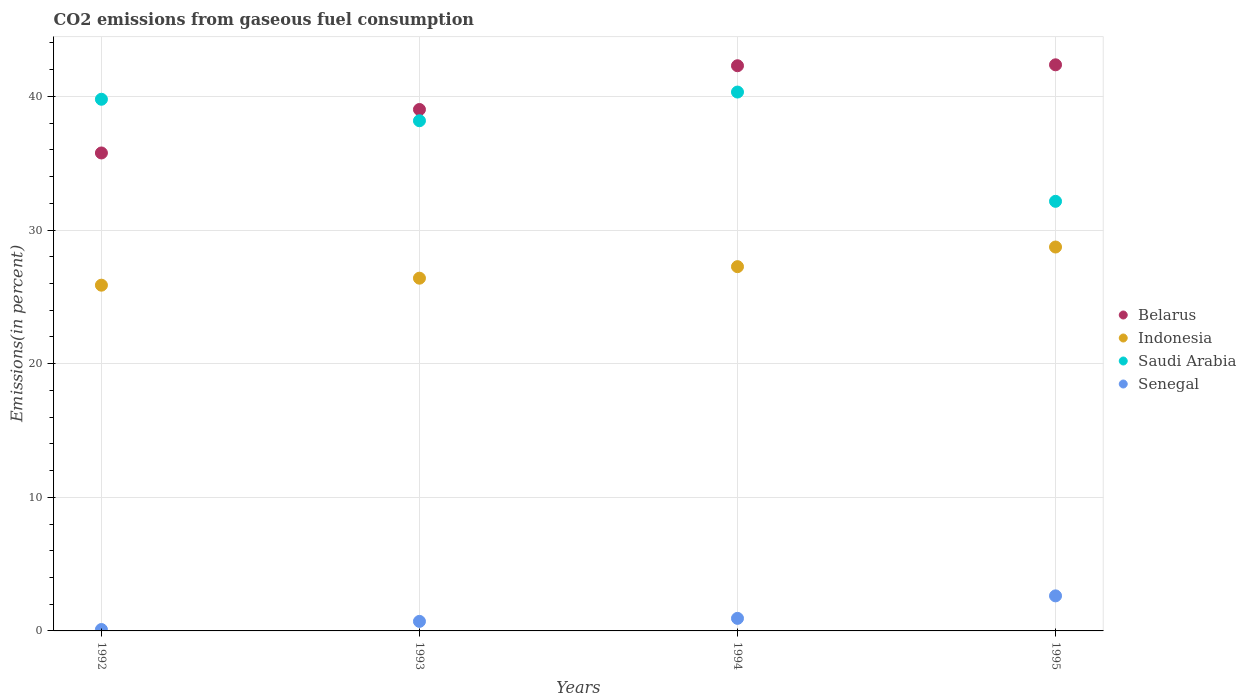How many different coloured dotlines are there?
Provide a succinct answer. 4. Is the number of dotlines equal to the number of legend labels?
Ensure brevity in your answer.  Yes. What is the total CO2 emitted in Senegal in 1994?
Provide a succinct answer. 0.94. Across all years, what is the maximum total CO2 emitted in Indonesia?
Ensure brevity in your answer.  28.73. Across all years, what is the minimum total CO2 emitted in Senegal?
Keep it short and to the point. 0.11. What is the total total CO2 emitted in Indonesia in the graph?
Make the answer very short. 108.26. What is the difference between the total CO2 emitted in Indonesia in 1994 and that in 1995?
Offer a terse response. -1.47. What is the difference between the total CO2 emitted in Saudi Arabia in 1993 and the total CO2 emitted in Senegal in 1994?
Give a very brief answer. 37.24. What is the average total CO2 emitted in Belarus per year?
Your answer should be compact. 39.86. In the year 1995, what is the difference between the total CO2 emitted in Senegal and total CO2 emitted in Indonesia?
Your answer should be very brief. -26.11. What is the ratio of the total CO2 emitted in Belarus in 1992 to that in 1993?
Give a very brief answer. 0.92. Is the total CO2 emitted in Belarus in 1993 less than that in 1994?
Your answer should be compact. Yes. What is the difference between the highest and the second highest total CO2 emitted in Indonesia?
Provide a short and direct response. 1.47. What is the difference between the highest and the lowest total CO2 emitted in Saudi Arabia?
Offer a very short reply. 8.18. In how many years, is the total CO2 emitted in Indonesia greater than the average total CO2 emitted in Indonesia taken over all years?
Your response must be concise. 2. Is it the case that in every year, the sum of the total CO2 emitted in Indonesia and total CO2 emitted in Belarus  is greater than the sum of total CO2 emitted in Saudi Arabia and total CO2 emitted in Senegal?
Your answer should be compact. Yes. Is the total CO2 emitted in Indonesia strictly greater than the total CO2 emitted in Senegal over the years?
Give a very brief answer. Yes. Is the total CO2 emitted in Saudi Arabia strictly less than the total CO2 emitted in Belarus over the years?
Your response must be concise. No. Are the values on the major ticks of Y-axis written in scientific E-notation?
Your answer should be very brief. No. Does the graph contain grids?
Offer a terse response. Yes. What is the title of the graph?
Provide a succinct answer. CO2 emissions from gaseous fuel consumption. What is the label or title of the X-axis?
Your answer should be very brief. Years. What is the label or title of the Y-axis?
Ensure brevity in your answer.  Emissions(in percent). What is the Emissions(in percent) of Belarus in 1992?
Your answer should be compact. 35.77. What is the Emissions(in percent) in Indonesia in 1992?
Keep it short and to the point. 25.87. What is the Emissions(in percent) of Saudi Arabia in 1992?
Give a very brief answer. 39.79. What is the Emissions(in percent) in Senegal in 1992?
Ensure brevity in your answer.  0.11. What is the Emissions(in percent) in Belarus in 1993?
Ensure brevity in your answer.  39.02. What is the Emissions(in percent) of Indonesia in 1993?
Your answer should be compact. 26.4. What is the Emissions(in percent) of Saudi Arabia in 1993?
Your response must be concise. 38.18. What is the Emissions(in percent) in Senegal in 1993?
Keep it short and to the point. 0.71. What is the Emissions(in percent) in Belarus in 1994?
Your answer should be compact. 42.3. What is the Emissions(in percent) in Indonesia in 1994?
Offer a very short reply. 27.26. What is the Emissions(in percent) in Saudi Arabia in 1994?
Make the answer very short. 40.33. What is the Emissions(in percent) of Senegal in 1994?
Provide a short and direct response. 0.94. What is the Emissions(in percent) in Belarus in 1995?
Make the answer very short. 42.37. What is the Emissions(in percent) of Indonesia in 1995?
Your answer should be compact. 28.73. What is the Emissions(in percent) of Saudi Arabia in 1995?
Offer a terse response. 32.15. What is the Emissions(in percent) of Senegal in 1995?
Your answer should be compact. 2.62. Across all years, what is the maximum Emissions(in percent) of Belarus?
Your answer should be compact. 42.37. Across all years, what is the maximum Emissions(in percent) in Indonesia?
Offer a terse response. 28.73. Across all years, what is the maximum Emissions(in percent) of Saudi Arabia?
Provide a short and direct response. 40.33. Across all years, what is the maximum Emissions(in percent) in Senegal?
Your response must be concise. 2.62. Across all years, what is the minimum Emissions(in percent) of Belarus?
Your answer should be compact. 35.77. Across all years, what is the minimum Emissions(in percent) in Indonesia?
Your answer should be compact. 25.87. Across all years, what is the minimum Emissions(in percent) in Saudi Arabia?
Provide a succinct answer. 32.15. Across all years, what is the minimum Emissions(in percent) in Senegal?
Keep it short and to the point. 0.11. What is the total Emissions(in percent) in Belarus in the graph?
Make the answer very short. 159.46. What is the total Emissions(in percent) in Indonesia in the graph?
Ensure brevity in your answer.  108.26. What is the total Emissions(in percent) in Saudi Arabia in the graph?
Provide a short and direct response. 150.45. What is the total Emissions(in percent) of Senegal in the graph?
Offer a very short reply. 4.38. What is the difference between the Emissions(in percent) in Belarus in 1992 and that in 1993?
Your answer should be very brief. -3.25. What is the difference between the Emissions(in percent) in Indonesia in 1992 and that in 1993?
Make the answer very short. -0.52. What is the difference between the Emissions(in percent) in Saudi Arabia in 1992 and that in 1993?
Ensure brevity in your answer.  1.61. What is the difference between the Emissions(in percent) in Senegal in 1992 and that in 1993?
Your answer should be very brief. -0.61. What is the difference between the Emissions(in percent) of Belarus in 1992 and that in 1994?
Provide a short and direct response. -6.53. What is the difference between the Emissions(in percent) of Indonesia in 1992 and that in 1994?
Keep it short and to the point. -1.39. What is the difference between the Emissions(in percent) in Saudi Arabia in 1992 and that in 1994?
Keep it short and to the point. -0.54. What is the difference between the Emissions(in percent) in Senegal in 1992 and that in 1994?
Provide a succinct answer. -0.83. What is the difference between the Emissions(in percent) in Belarus in 1992 and that in 1995?
Make the answer very short. -6.6. What is the difference between the Emissions(in percent) in Indonesia in 1992 and that in 1995?
Offer a terse response. -2.86. What is the difference between the Emissions(in percent) in Saudi Arabia in 1992 and that in 1995?
Offer a very short reply. 7.64. What is the difference between the Emissions(in percent) of Senegal in 1992 and that in 1995?
Offer a very short reply. -2.52. What is the difference between the Emissions(in percent) of Belarus in 1993 and that in 1994?
Make the answer very short. -3.27. What is the difference between the Emissions(in percent) of Indonesia in 1993 and that in 1994?
Offer a very short reply. -0.86. What is the difference between the Emissions(in percent) in Saudi Arabia in 1993 and that in 1994?
Keep it short and to the point. -2.15. What is the difference between the Emissions(in percent) in Senegal in 1993 and that in 1994?
Provide a succinct answer. -0.23. What is the difference between the Emissions(in percent) of Belarus in 1993 and that in 1995?
Ensure brevity in your answer.  -3.34. What is the difference between the Emissions(in percent) in Indonesia in 1993 and that in 1995?
Provide a succinct answer. -2.33. What is the difference between the Emissions(in percent) in Saudi Arabia in 1993 and that in 1995?
Your answer should be very brief. 6.03. What is the difference between the Emissions(in percent) of Senegal in 1993 and that in 1995?
Your answer should be very brief. -1.91. What is the difference between the Emissions(in percent) of Belarus in 1994 and that in 1995?
Provide a succinct answer. -0.07. What is the difference between the Emissions(in percent) of Indonesia in 1994 and that in 1995?
Your answer should be very brief. -1.47. What is the difference between the Emissions(in percent) in Saudi Arabia in 1994 and that in 1995?
Ensure brevity in your answer.  8.18. What is the difference between the Emissions(in percent) in Senegal in 1994 and that in 1995?
Offer a terse response. -1.68. What is the difference between the Emissions(in percent) of Belarus in 1992 and the Emissions(in percent) of Indonesia in 1993?
Your answer should be very brief. 9.37. What is the difference between the Emissions(in percent) of Belarus in 1992 and the Emissions(in percent) of Saudi Arabia in 1993?
Your answer should be very brief. -2.41. What is the difference between the Emissions(in percent) in Belarus in 1992 and the Emissions(in percent) in Senegal in 1993?
Provide a succinct answer. 35.06. What is the difference between the Emissions(in percent) of Indonesia in 1992 and the Emissions(in percent) of Saudi Arabia in 1993?
Ensure brevity in your answer.  -12.31. What is the difference between the Emissions(in percent) in Indonesia in 1992 and the Emissions(in percent) in Senegal in 1993?
Offer a terse response. 25.16. What is the difference between the Emissions(in percent) of Saudi Arabia in 1992 and the Emissions(in percent) of Senegal in 1993?
Offer a very short reply. 39.07. What is the difference between the Emissions(in percent) of Belarus in 1992 and the Emissions(in percent) of Indonesia in 1994?
Offer a terse response. 8.51. What is the difference between the Emissions(in percent) in Belarus in 1992 and the Emissions(in percent) in Saudi Arabia in 1994?
Keep it short and to the point. -4.56. What is the difference between the Emissions(in percent) in Belarus in 1992 and the Emissions(in percent) in Senegal in 1994?
Offer a terse response. 34.83. What is the difference between the Emissions(in percent) of Indonesia in 1992 and the Emissions(in percent) of Saudi Arabia in 1994?
Give a very brief answer. -14.45. What is the difference between the Emissions(in percent) in Indonesia in 1992 and the Emissions(in percent) in Senegal in 1994?
Keep it short and to the point. 24.93. What is the difference between the Emissions(in percent) of Saudi Arabia in 1992 and the Emissions(in percent) of Senegal in 1994?
Keep it short and to the point. 38.85. What is the difference between the Emissions(in percent) in Belarus in 1992 and the Emissions(in percent) in Indonesia in 1995?
Provide a short and direct response. 7.04. What is the difference between the Emissions(in percent) in Belarus in 1992 and the Emissions(in percent) in Saudi Arabia in 1995?
Offer a very short reply. 3.62. What is the difference between the Emissions(in percent) in Belarus in 1992 and the Emissions(in percent) in Senegal in 1995?
Make the answer very short. 33.15. What is the difference between the Emissions(in percent) in Indonesia in 1992 and the Emissions(in percent) in Saudi Arabia in 1995?
Provide a short and direct response. -6.28. What is the difference between the Emissions(in percent) of Indonesia in 1992 and the Emissions(in percent) of Senegal in 1995?
Provide a succinct answer. 23.25. What is the difference between the Emissions(in percent) in Saudi Arabia in 1992 and the Emissions(in percent) in Senegal in 1995?
Your response must be concise. 37.17. What is the difference between the Emissions(in percent) in Belarus in 1993 and the Emissions(in percent) in Indonesia in 1994?
Your answer should be compact. 11.76. What is the difference between the Emissions(in percent) in Belarus in 1993 and the Emissions(in percent) in Saudi Arabia in 1994?
Offer a terse response. -1.3. What is the difference between the Emissions(in percent) in Belarus in 1993 and the Emissions(in percent) in Senegal in 1994?
Offer a terse response. 38.08. What is the difference between the Emissions(in percent) in Indonesia in 1993 and the Emissions(in percent) in Saudi Arabia in 1994?
Make the answer very short. -13.93. What is the difference between the Emissions(in percent) in Indonesia in 1993 and the Emissions(in percent) in Senegal in 1994?
Offer a terse response. 25.46. What is the difference between the Emissions(in percent) in Saudi Arabia in 1993 and the Emissions(in percent) in Senegal in 1994?
Keep it short and to the point. 37.24. What is the difference between the Emissions(in percent) of Belarus in 1993 and the Emissions(in percent) of Indonesia in 1995?
Ensure brevity in your answer.  10.29. What is the difference between the Emissions(in percent) of Belarus in 1993 and the Emissions(in percent) of Saudi Arabia in 1995?
Offer a terse response. 6.87. What is the difference between the Emissions(in percent) of Belarus in 1993 and the Emissions(in percent) of Senegal in 1995?
Ensure brevity in your answer.  36.4. What is the difference between the Emissions(in percent) in Indonesia in 1993 and the Emissions(in percent) in Saudi Arabia in 1995?
Keep it short and to the point. -5.75. What is the difference between the Emissions(in percent) of Indonesia in 1993 and the Emissions(in percent) of Senegal in 1995?
Make the answer very short. 23.78. What is the difference between the Emissions(in percent) of Saudi Arabia in 1993 and the Emissions(in percent) of Senegal in 1995?
Your answer should be very brief. 35.56. What is the difference between the Emissions(in percent) in Belarus in 1994 and the Emissions(in percent) in Indonesia in 1995?
Your answer should be compact. 13.57. What is the difference between the Emissions(in percent) in Belarus in 1994 and the Emissions(in percent) in Saudi Arabia in 1995?
Provide a succinct answer. 10.15. What is the difference between the Emissions(in percent) of Belarus in 1994 and the Emissions(in percent) of Senegal in 1995?
Give a very brief answer. 39.67. What is the difference between the Emissions(in percent) in Indonesia in 1994 and the Emissions(in percent) in Saudi Arabia in 1995?
Ensure brevity in your answer.  -4.89. What is the difference between the Emissions(in percent) of Indonesia in 1994 and the Emissions(in percent) of Senegal in 1995?
Make the answer very short. 24.64. What is the difference between the Emissions(in percent) of Saudi Arabia in 1994 and the Emissions(in percent) of Senegal in 1995?
Keep it short and to the point. 37.71. What is the average Emissions(in percent) of Belarus per year?
Offer a very short reply. 39.86. What is the average Emissions(in percent) in Indonesia per year?
Your answer should be compact. 27.07. What is the average Emissions(in percent) in Saudi Arabia per year?
Provide a short and direct response. 37.61. What is the average Emissions(in percent) in Senegal per year?
Ensure brevity in your answer.  1.1. In the year 1992, what is the difference between the Emissions(in percent) of Belarus and Emissions(in percent) of Indonesia?
Give a very brief answer. 9.9. In the year 1992, what is the difference between the Emissions(in percent) of Belarus and Emissions(in percent) of Saudi Arabia?
Make the answer very short. -4.02. In the year 1992, what is the difference between the Emissions(in percent) in Belarus and Emissions(in percent) in Senegal?
Give a very brief answer. 35.66. In the year 1992, what is the difference between the Emissions(in percent) in Indonesia and Emissions(in percent) in Saudi Arabia?
Offer a very short reply. -13.91. In the year 1992, what is the difference between the Emissions(in percent) in Indonesia and Emissions(in percent) in Senegal?
Provide a succinct answer. 25.77. In the year 1992, what is the difference between the Emissions(in percent) in Saudi Arabia and Emissions(in percent) in Senegal?
Keep it short and to the point. 39.68. In the year 1993, what is the difference between the Emissions(in percent) of Belarus and Emissions(in percent) of Indonesia?
Offer a very short reply. 12.63. In the year 1993, what is the difference between the Emissions(in percent) in Belarus and Emissions(in percent) in Saudi Arabia?
Provide a short and direct response. 0.84. In the year 1993, what is the difference between the Emissions(in percent) in Belarus and Emissions(in percent) in Senegal?
Offer a very short reply. 38.31. In the year 1993, what is the difference between the Emissions(in percent) of Indonesia and Emissions(in percent) of Saudi Arabia?
Your response must be concise. -11.78. In the year 1993, what is the difference between the Emissions(in percent) of Indonesia and Emissions(in percent) of Senegal?
Provide a succinct answer. 25.68. In the year 1993, what is the difference between the Emissions(in percent) of Saudi Arabia and Emissions(in percent) of Senegal?
Provide a succinct answer. 37.47. In the year 1994, what is the difference between the Emissions(in percent) in Belarus and Emissions(in percent) in Indonesia?
Your response must be concise. 15.04. In the year 1994, what is the difference between the Emissions(in percent) in Belarus and Emissions(in percent) in Saudi Arabia?
Ensure brevity in your answer.  1.97. In the year 1994, what is the difference between the Emissions(in percent) in Belarus and Emissions(in percent) in Senegal?
Offer a terse response. 41.36. In the year 1994, what is the difference between the Emissions(in percent) of Indonesia and Emissions(in percent) of Saudi Arabia?
Offer a terse response. -13.07. In the year 1994, what is the difference between the Emissions(in percent) in Indonesia and Emissions(in percent) in Senegal?
Make the answer very short. 26.32. In the year 1994, what is the difference between the Emissions(in percent) in Saudi Arabia and Emissions(in percent) in Senegal?
Your answer should be compact. 39.39. In the year 1995, what is the difference between the Emissions(in percent) of Belarus and Emissions(in percent) of Indonesia?
Your answer should be very brief. 13.64. In the year 1995, what is the difference between the Emissions(in percent) in Belarus and Emissions(in percent) in Saudi Arabia?
Provide a short and direct response. 10.22. In the year 1995, what is the difference between the Emissions(in percent) of Belarus and Emissions(in percent) of Senegal?
Your answer should be compact. 39.74. In the year 1995, what is the difference between the Emissions(in percent) in Indonesia and Emissions(in percent) in Saudi Arabia?
Offer a terse response. -3.42. In the year 1995, what is the difference between the Emissions(in percent) of Indonesia and Emissions(in percent) of Senegal?
Your answer should be very brief. 26.11. In the year 1995, what is the difference between the Emissions(in percent) of Saudi Arabia and Emissions(in percent) of Senegal?
Offer a terse response. 29.53. What is the ratio of the Emissions(in percent) in Belarus in 1992 to that in 1993?
Your response must be concise. 0.92. What is the ratio of the Emissions(in percent) in Indonesia in 1992 to that in 1993?
Make the answer very short. 0.98. What is the ratio of the Emissions(in percent) of Saudi Arabia in 1992 to that in 1993?
Provide a short and direct response. 1.04. What is the ratio of the Emissions(in percent) in Senegal in 1992 to that in 1993?
Your answer should be very brief. 0.15. What is the ratio of the Emissions(in percent) of Belarus in 1992 to that in 1994?
Ensure brevity in your answer.  0.85. What is the ratio of the Emissions(in percent) of Indonesia in 1992 to that in 1994?
Ensure brevity in your answer.  0.95. What is the ratio of the Emissions(in percent) of Saudi Arabia in 1992 to that in 1994?
Offer a very short reply. 0.99. What is the ratio of the Emissions(in percent) of Senegal in 1992 to that in 1994?
Offer a terse response. 0.11. What is the ratio of the Emissions(in percent) of Belarus in 1992 to that in 1995?
Your answer should be compact. 0.84. What is the ratio of the Emissions(in percent) of Indonesia in 1992 to that in 1995?
Your response must be concise. 0.9. What is the ratio of the Emissions(in percent) of Saudi Arabia in 1992 to that in 1995?
Your answer should be very brief. 1.24. What is the ratio of the Emissions(in percent) in Senegal in 1992 to that in 1995?
Keep it short and to the point. 0.04. What is the ratio of the Emissions(in percent) in Belarus in 1993 to that in 1994?
Your response must be concise. 0.92. What is the ratio of the Emissions(in percent) of Indonesia in 1993 to that in 1994?
Give a very brief answer. 0.97. What is the ratio of the Emissions(in percent) of Saudi Arabia in 1993 to that in 1994?
Give a very brief answer. 0.95. What is the ratio of the Emissions(in percent) in Senegal in 1993 to that in 1994?
Offer a very short reply. 0.76. What is the ratio of the Emissions(in percent) in Belarus in 1993 to that in 1995?
Offer a terse response. 0.92. What is the ratio of the Emissions(in percent) of Indonesia in 1993 to that in 1995?
Offer a very short reply. 0.92. What is the ratio of the Emissions(in percent) of Saudi Arabia in 1993 to that in 1995?
Ensure brevity in your answer.  1.19. What is the ratio of the Emissions(in percent) in Senegal in 1993 to that in 1995?
Your answer should be compact. 0.27. What is the ratio of the Emissions(in percent) in Belarus in 1994 to that in 1995?
Keep it short and to the point. 1. What is the ratio of the Emissions(in percent) in Indonesia in 1994 to that in 1995?
Your response must be concise. 0.95. What is the ratio of the Emissions(in percent) in Saudi Arabia in 1994 to that in 1995?
Keep it short and to the point. 1.25. What is the ratio of the Emissions(in percent) in Senegal in 1994 to that in 1995?
Your response must be concise. 0.36. What is the difference between the highest and the second highest Emissions(in percent) in Belarus?
Provide a succinct answer. 0.07. What is the difference between the highest and the second highest Emissions(in percent) of Indonesia?
Provide a succinct answer. 1.47. What is the difference between the highest and the second highest Emissions(in percent) of Saudi Arabia?
Keep it short and to the point. 0.54. What is the difference between the highest and the second highest Emissions(in percent) in Senegal?
Provide a succinct answer. 1.68. What is the difference between the highest and the lowest Emissions(in percent) in Belarus?
Make the answer very short. 6.6. What is the difference between the highest and the lowest Emissions(in percent) of Indonesia?
Give a very brief answer. 2.86. What is the difference between the highest and the lowest Emissions(in percent) of Saudi Arabia?
Offer a terse response. 8.18. What is the difference between the highest and the lowest Emissions(in percent) in Senegal?
Provide a succinct answer. 2.52. 